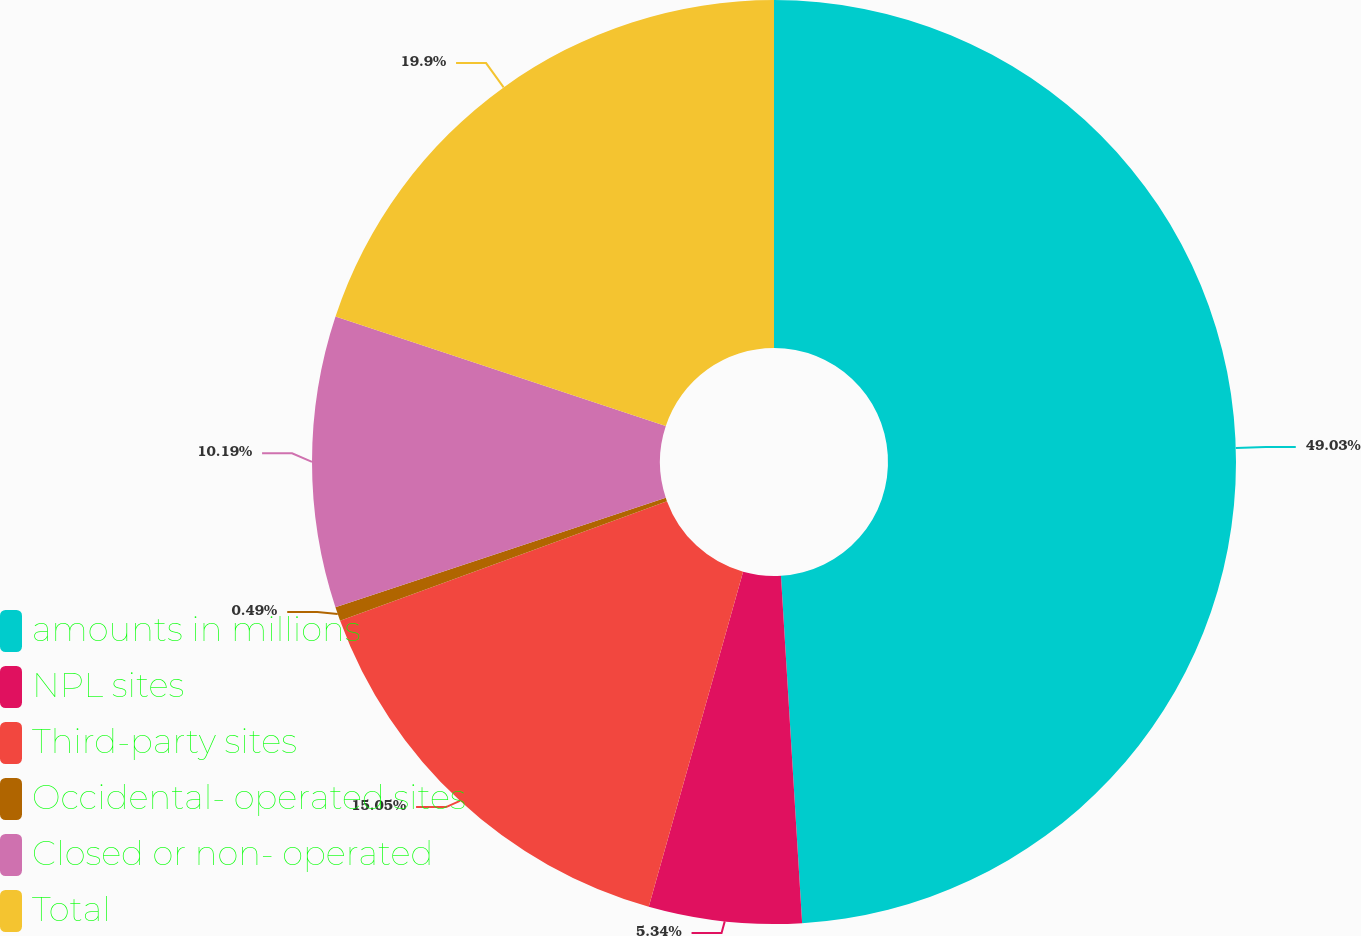Convert chart. <chart><loc_0><loc_0><loc_500><loc_500><pie_chart><fcel>amounts in millions<fcel>NPL sites<fcel>Third-party sites<fcel>Occidental- operated sites<fcel>Closed or non- operated<fcel>Total<nl><fcel>49.03%<fcel>5.34%<fcel>15.05%<fcel>0.49%<fcel>10.19%<fcel>19.9%<nl></chart> 